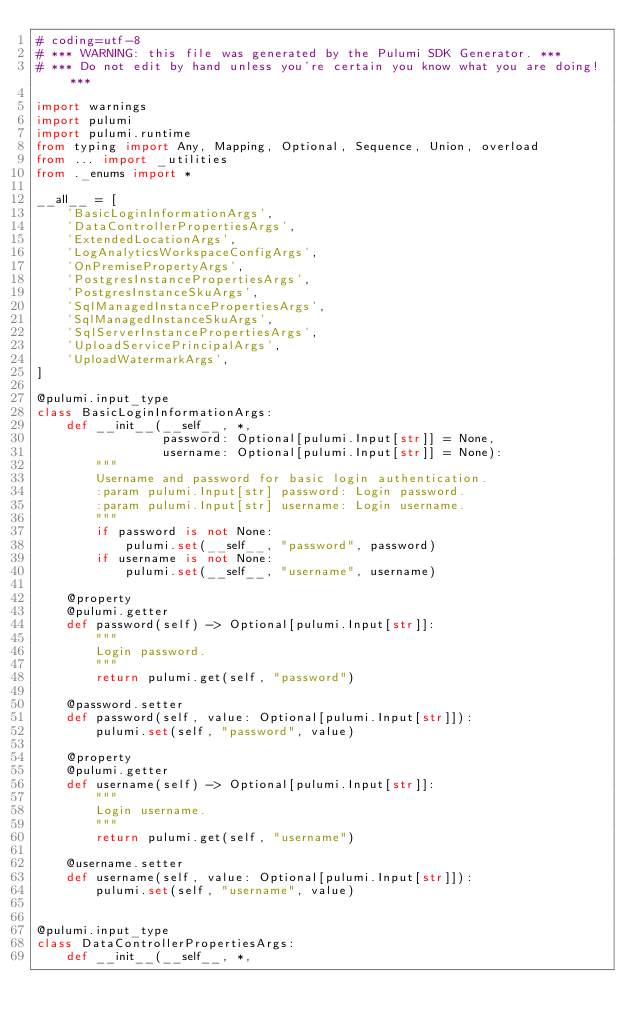<code> <loc_0><loc_0><loc_500><loc_500><_Python_># coding=utf-8
# *** WARNING: this file was generated by the Pulumi SDK Generator. ***
# *** Do not edit by hand unless you're certain you know what you are doing! ***

import warnings
import pulumi
import pulumi.runtime
from typing import Any, Mapping, Optional, Sequence, Union, overload
from ... import _utilities
from ._enums import *

__all__ = [
    'BasicLoginInformationArgs',
    'DataControllerPropertiesArgs',
    'ExtendedLocationArgs',
    'LogAnalyticsWorkspaceConfigArgs',
    'OnPremisePropertyArgs',
    'PostgresInstancePropertiesArgs',
    'PostgresInstanceSkuArgs',
    'SqlManagedInstancePropertiesArgs',
    'SqlManagedInstanceSkuArgs',
    'SqlServerInstancePropertiesArgs',
    'UploadServicePrincipalArgs',
    'UploadWatermarkArgs',
]

@pulumi.input_type
class BasicLoginInformationArgs:
    def __init__(__self__, *,
                 password: Optional[pulumi.Input[str]] = None,
                 username: Optional[pulumi.Input[str]] = None):
        """
        Username and password for basic login authentication.
        :param pulumi.Input[str] password: Login password.
        :param pulumi.Input[str] username: Login username.
        """
        if password is not None:
            pulumi.set(__self__, "password", password)
        if username is not None:
            pulumi.set(__self__, "username", username)

    @property
    @pulumi.getter
    def password(self) -> Optional[pulumi.Input[str]]:
        """
        Login password.
        """
        return pulumi.get(self, "password")

    @password.setter
    def password(self, value: Optional[pulumi.Input[str]]):
        pulumi.set(self, "password", value)

    @property
    @pulumi.getter
    def username(self) -> Optional[pulumi.Input[str]]:
        """
        Login username.
        """
        return pulumi.get(self, "username")

    @username.setter
    def username(self, value: Optional[pulumi.Input[str]]):
        pulumi.set(self, "username", value)


@pulumi.input_type
class DataControllerPropertiesArgs:
    def __init__(__self__, *,</code> 